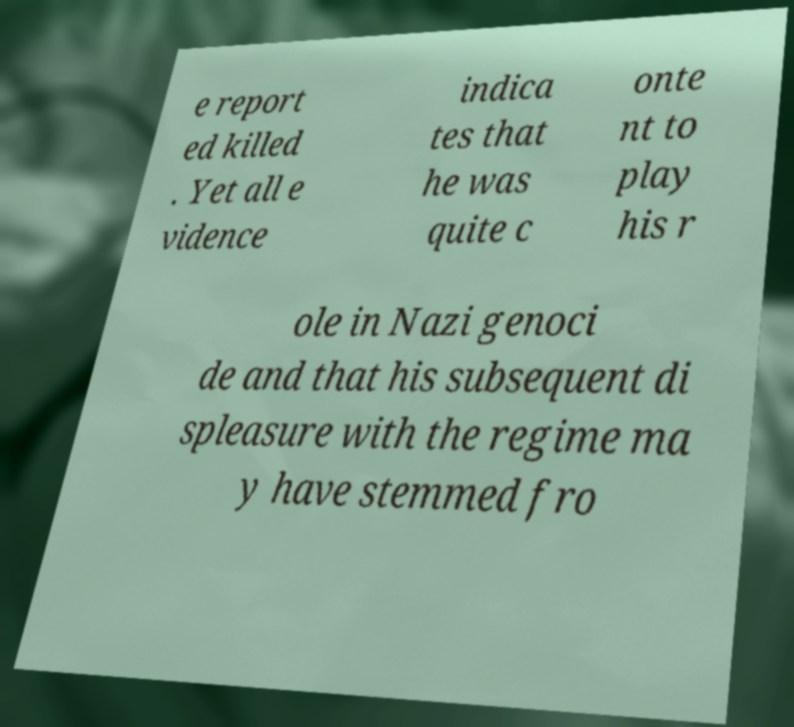For documentation purposes, I need the text within this image transcribed. Could you provide that? e report ed killed . Yet all e vidence indica tes that he was quite c onte nt to play his r ole in Nazi genoci de and that his subsequent di spleasure with the regime ma y have stemmed fro 